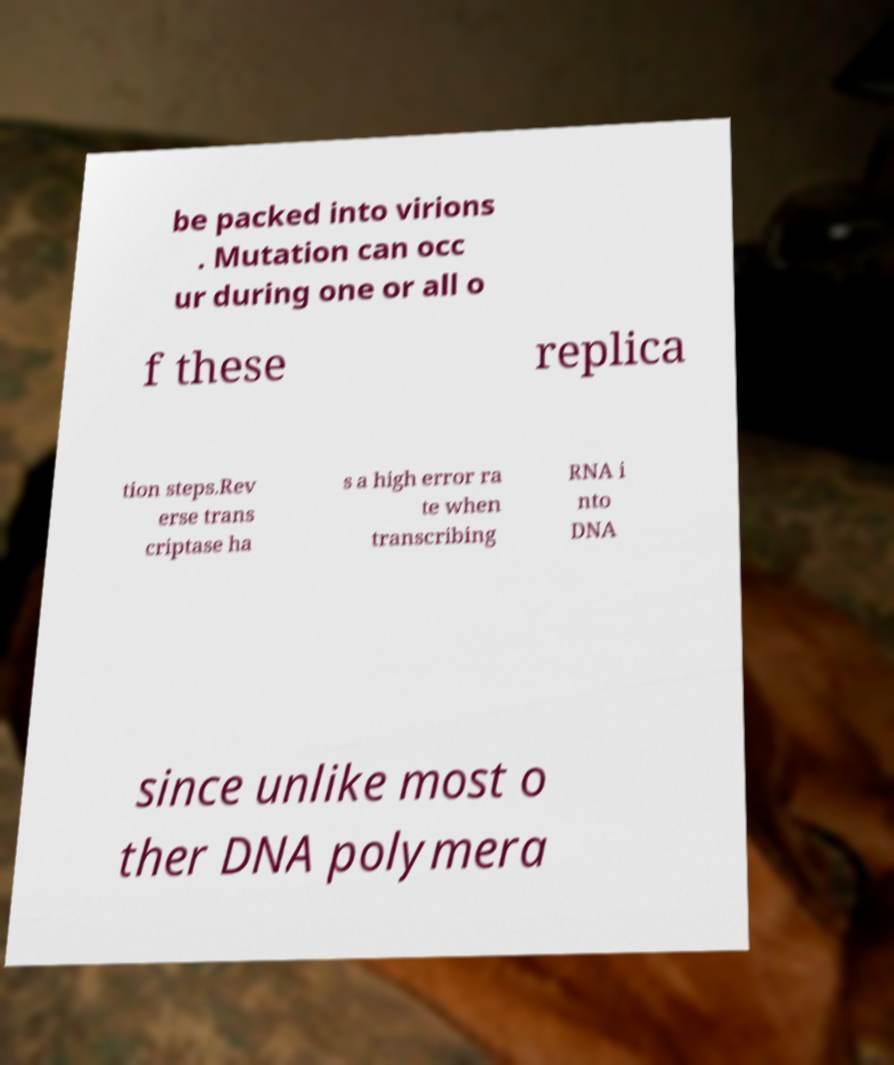I need the written content from this picture converted into text. Can you do that? be packed into virions . Mutation can occ ur during one or all o f these replica tion steps.Rev erse trans criptase ha s a high error ra te when transcribing RNA i nto DNA since unlike most o ther DNA polymera 